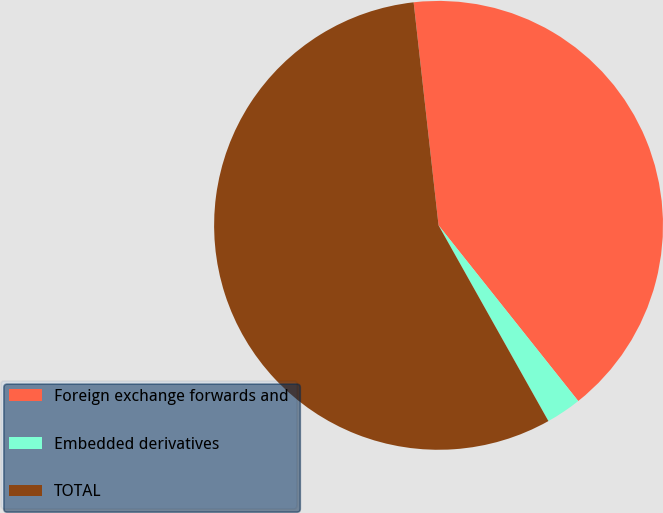<chart> <loc_0><loc_0><loc_500><loc_500><pie_chart><fcel>Foreign exchange forwards and<fcel>Embedded derivatives<fcel>TOTAL<nl><fcel>41.08%<fcel>2.55%<fcel>56.37%<nl></chart> 